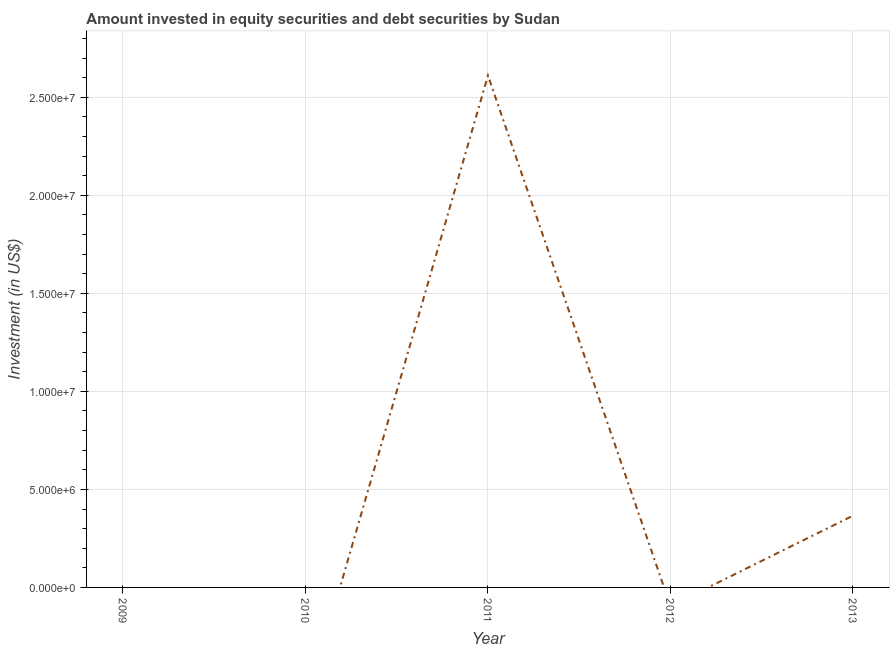What is the portfolio investment in 2013?
Your answer should be compact. 3.66e+06. Across all years, what is the maximum portfolio investment?
Offer a terse response. 2.61e+07. Across all years, what is the minimum portfolio investment?
Give a very brief answer. 0. What is the sum of the portfolio investment?
Give a very brief answer. 2.98e+07. What is the average portfolio investment per year?
Provide a short and direct response. 5.95e+06. What is the median portfolio investment?
Your answer should be very brief. 0. Is the sum of the portfolio investment in 2011 and 2013 greater than the maximum portfolio investment across all years?
Keep it short and to the point. Yes. What is the difference between the highest and the lowest portfolio investment?
Provide a short and direct response. 2.61e+07. How many lines are there?
Keep it short and to the point. 1. Are the values on the major ticks of Y-axis written in scientific E-notation?
Your answer should be very brief. Yes. What is the title of the graph?
Your answer should be very brief. Amount invested in equity securities and debt securities by Sudan. What is the label or title of the X-axis?
Give a very brief answer. Year. What is the label or title of the Y-axis?
Ensure brevity in your answer.  Investment (in US$). What is the Investment (in US$) of 2011?
Ensure brevity in your answer.  2.61e+07. What is the Investment (in US$) in 2012?
Offer a terse response. 0. What is the Investment (in US$) of 2013?
Provide a succinct answer. 3.66e+06. What is the difference between the Investment (in US$) in 2011 and 2013?
Your answer should be very brief. 2.25e+07. What is the ratio of the Investment (in US$) in 2011 to that in 2013?
Offer a terse response. 7.13. 